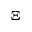Convert formula to latex. <formula><loc_0><loc_0><loc_500><loc_500>\Xi</formula> 